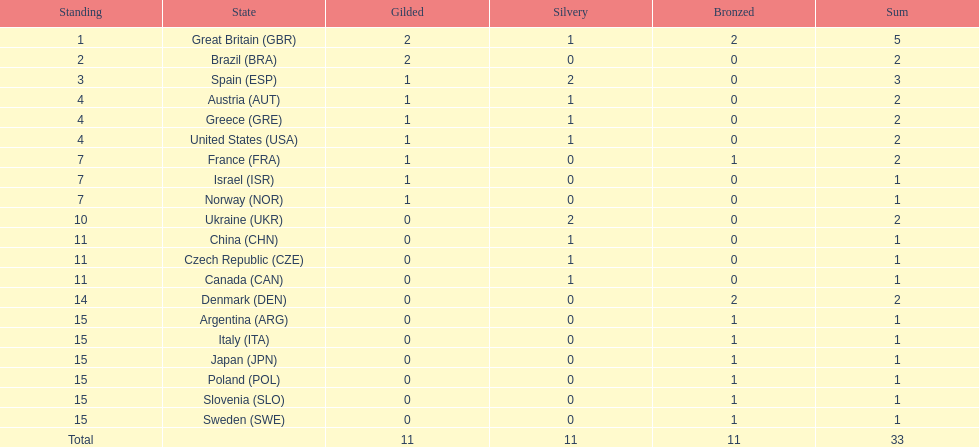What was the aggregate amount of medals earned by the united states? 2. 